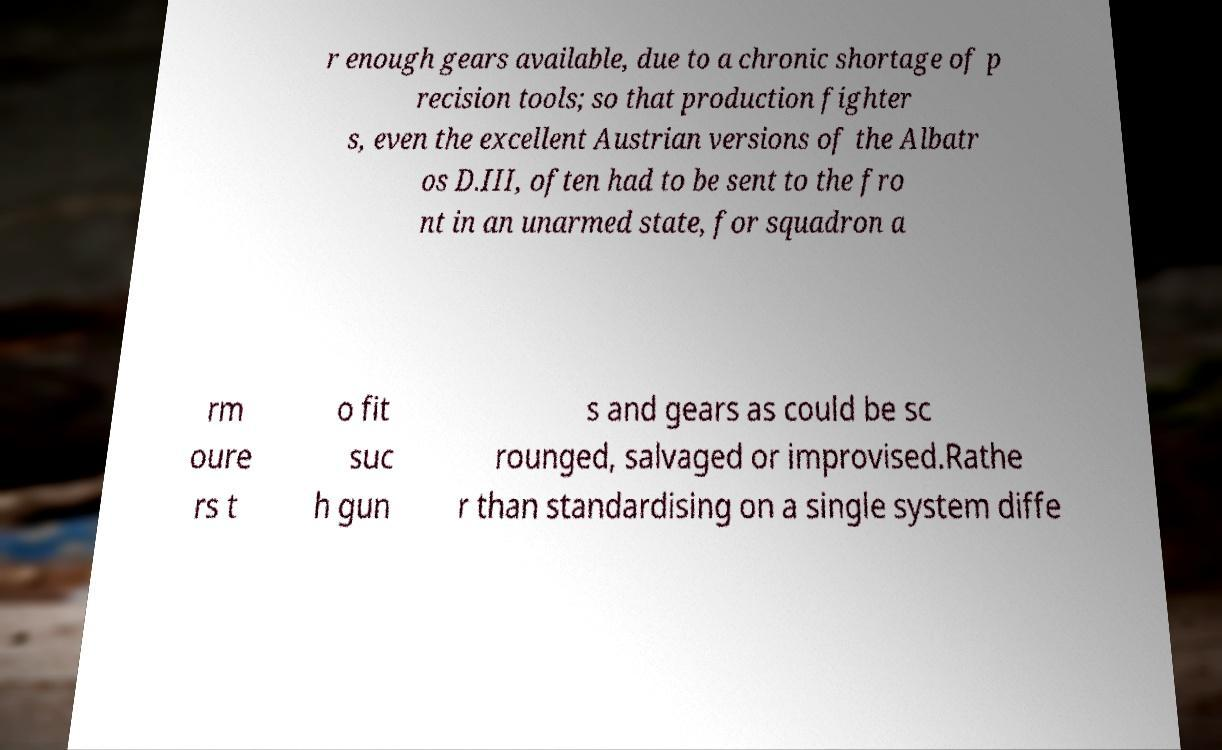Could you extract and type out the text from this image? r enough gears available, due to a chronic shortage of p recision tools; so that production fighter s, even the excellent Austrian versions of the Albatr os D.III, often had to be sent to the fro nt in an unarmed state, for squadron a rm oure rs t o fit suc h gun s and gears as could be sc rounged, salvaged or improvised.Rathe r than standardising on a single system diffe 